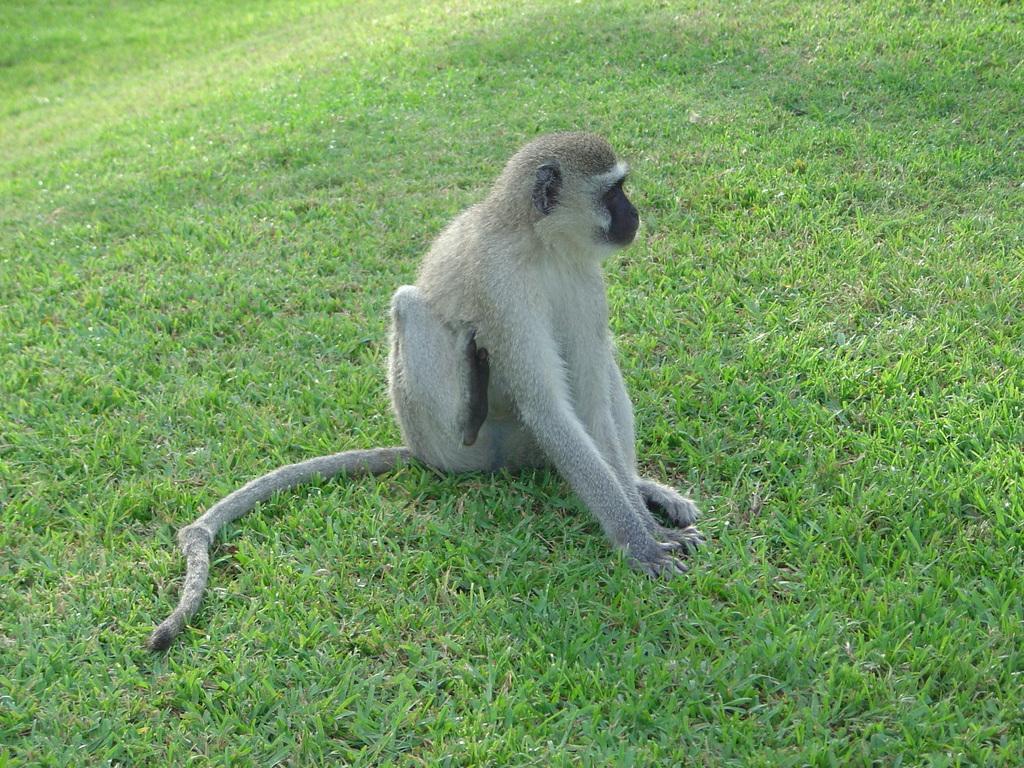How would you summarize this image in a sentence or two? In this image we can see a monkey on grassy land. 